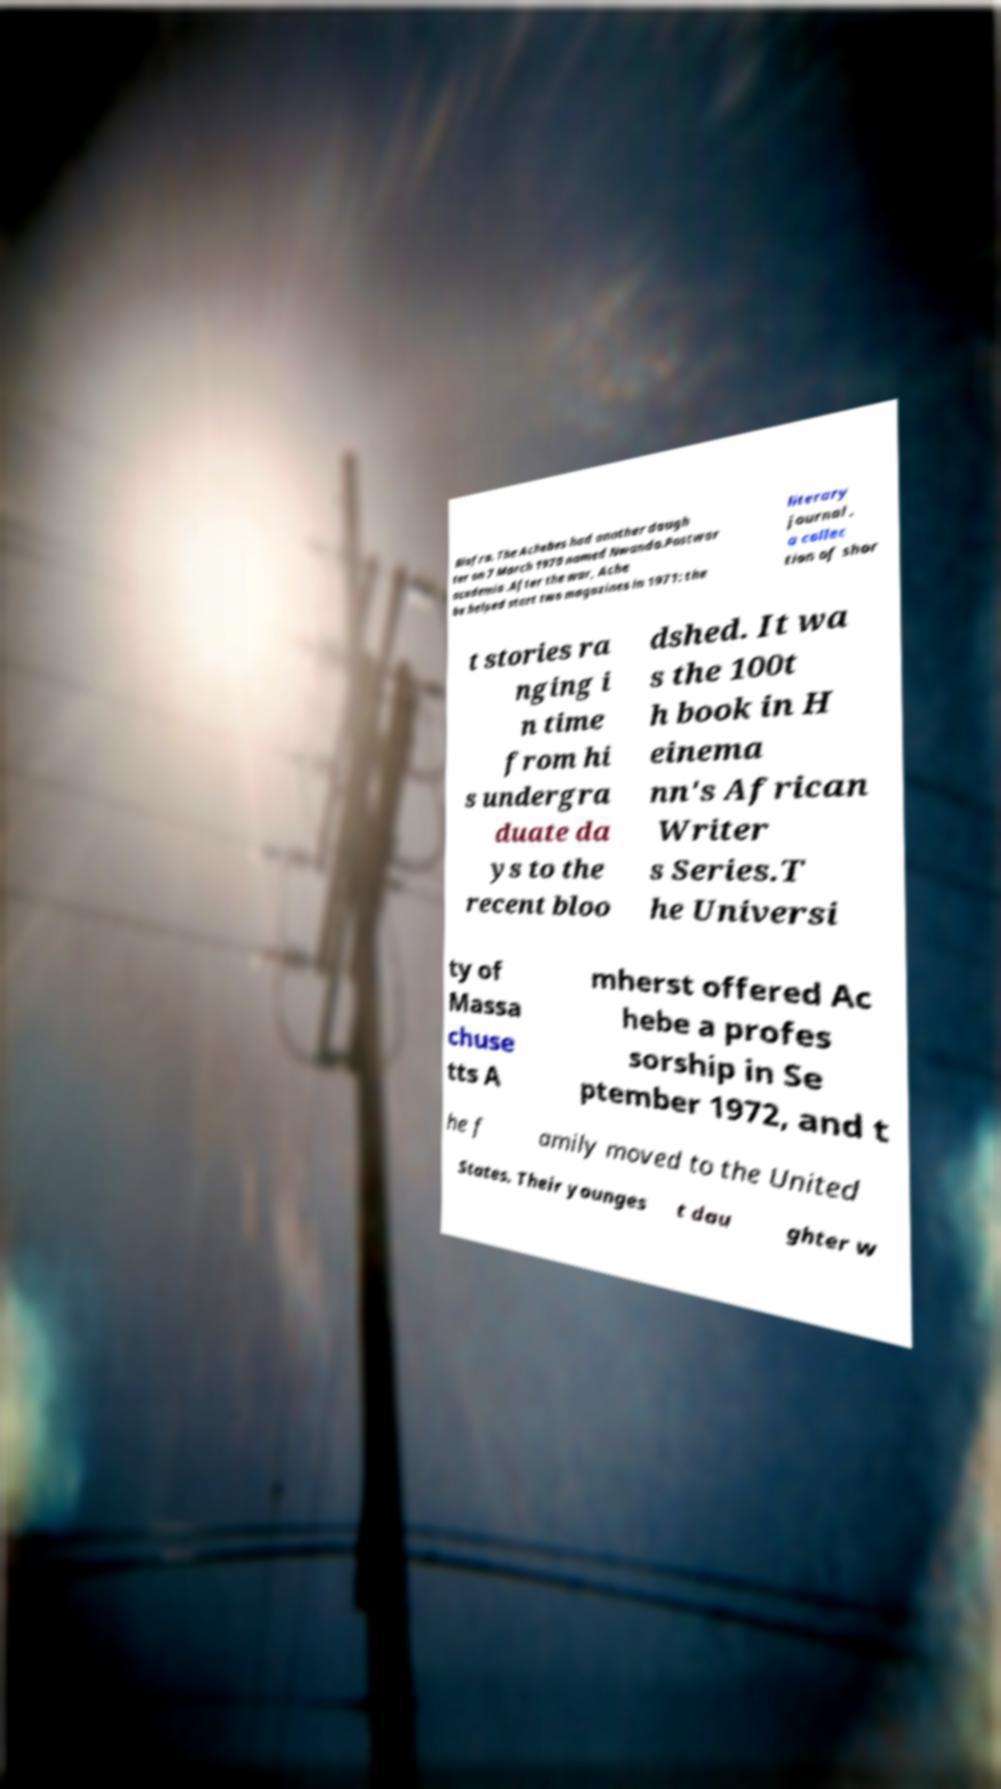Could you assist in decoding the text presented in this image and type it out clearly? Biafra. The Achebes had another daugh ter on 7 March 1970 named Nwando.Postwar academia .After the war, Ache be helped start two magazines in 1971: the literary journal , a collec tion of shor t stories ra nging i n time from hi s undergra duate da ys to the recent bloo dshed. It wa s the 100t h book in H einema nn's African Writer s Series.T he Universi ty of Massa chuse tts A mherst offered Ac hebe a profes sorship in Se ptember 1972, and t he f amily moved to the United States. Their younges t dau ghter w 